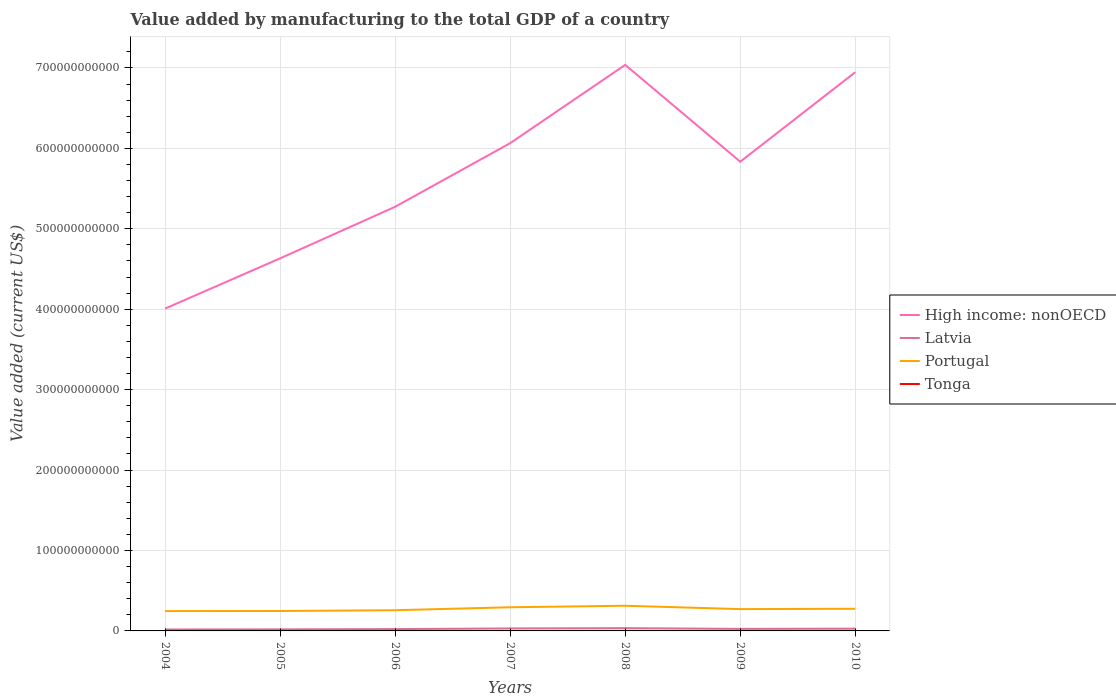Across all years, what is the maximum value added by manufacturing to the total GDP in Tonga?
Offer a terse response. 1.86e+07. In which year was the value added by manufacturing to the total GDP in Latvia maximum?
Your answer should be very brief. 2004. What is the total value added by manufacturing to the total GDP in Latvia in the graph?
Give a very brief answer. -7.93e+08. What is the difference between the highest and the second highest value added by manufacturing to the total GDP in Tonga?
Your answer should be very brief. 4.22e+06. How many years are there in the graph?
Provide a short and direct response. 7. What is the difference between two consecutive major ticks on the Y-axis?
Ensure brevity in your answer.  1.00e+11. Are the values on the major ticks of Y-axis written in scientific E-notation?
Your answer should be very brief. No. Does the graph contain grids?
Your response must be concise. Yes. Where does the legend appear in the graph?
Give a very brief answer. Center right. How are the legend labels stacked?
Ensure brevity in your answer.  Vertical. What is the title of the graph?
Ensure brevity in your answer.  Value added by manufacturing to the total GDP of a country. Does "Isle of Man" appear as one of the legend labels in the graph?
Provide a succinct answer. No. What is the label or title of the Y-axis?
Your response must be concise. Value added (current US$). What is the Value added (current US$) of High income: nonOECD in 2004?
Your response must be concise. 4.01e+11. What is the Value added (current US$) in Latvia in 2004?
Your answer should be compact. 1.78e+09. What is the Value added (current US$) of Portugal in 2004?
Your answer should be very brief. 2.47e+1. What is the Value added (current US$) in Tonga in 2004?
Your answer should be compact. 1.86e+07. What is the Value added (current US$) in High income: nonOECD in 2005?
Offer a very short reply. 4.63e+11. What is the Value added (current US$) in Latvia in 2005?
Provide a short and direct response. 1.95e+09. What is the Value added (current US$) of Portugal in 2005?
Your answer should be compact. 2.48e+1. What is the Value added (current US$) of Tonga in 2005?
Offer a very short reply. 1.94e+07. What is the Value added (current US$) in High income: nonOECD in 2006?
Your answer should be compact. 5.27e+11. What is the Value added (current US$) of Latvia in 2006?
Make the answer very short. 2.29e+09. What is the Value added (current US$) of Portugal in 2006?
Provide a short and direct response. 2.57e+1. What is the Value added (current US$) in Tonga in 2006?
Provide a short and direct response. 2.05e+07. What is the Value added (current US$) of High income: nonOECD in 2007?
Provide a short and direct response. 6.07e+11. What is the Value added (current US$) in Latvia in 2007?
Your answer should be very brief. 3.13e+09. What is the Value added (current US$) of Portugal in 2007?
Your answer should be compact. 2.94e+1. What is the Value added (current US$) in Tonga in 2007?
Provide a succinct answer. 2.17e+07. What is the Value added (current US$) of High income: nonOECD in 2008?
Give a very brief answer. 7.04e+11. What is the Value added (current US$) of Latvia in 2008?
Provide a short and direct response. 3.46e+09. What is the Value added (current US$) in Portugal in 2008?
Keep it short and to the point. 3.13e+1. What is the Value added (current US$) of Tonga in 2008?
Offer a very short reply. 2.29e+07. What is the Value added (current US$) in High income: nonOECD in 2009?
Ensure brevity in your answer.  5.83e+11. What is the Value added (current US$) in Latvia in 2009?
Your response must be concise. 2.57e+09. What is the Value added (current US$) of Portugal in 2009?
Offer a terse response. 2.71e+1. What is the Value added (current US$) in Tonga in 2009?
Offer a terse response. 2.13e+07. What is the Value added (current US$) in High income: nonOECD in 2010?
Your answer should be very brief. 6.95e+11. What is the Value added (current US$) in Latvia in 2010?
Offer a terse response. 2.86e+09. What is the Value added (current US$) of Portugal in 2010?
Your answer should be very brief. 2.76e+1. What is the Value added (current US$) of Tonga in 2010?
Your answer should be compact. 2.27e+07. Across all years, what is the maximum Value added (current US$) of High income: nonOECD?
Give a very brief answer. 7.04e+11. Across all years, what is the maximum Value added (current US$) of Latvia?
Your answer should be very brief. 3.46e+09. Across all years, what is the maximum Value added (current US$) of Portugal?
Your answer should be very brief. 3.13e+1. Across all years, what is the maximum Value added (current US$) in Tonga?
Provide a short and direct response. 2.29e+07. Across all years, what is the minimum Value added (current US$) of High income: nonOECD?
Offer a very short reply. 4.01e+11. Across all years, what is the minimum Value added (current US$) of Latvia?
Give a very brief answer. 1.78e+09. Across all years, what is the minimum Value added (current US$) in Portugal?
Offer a terse response. 2.47e+1. Across all years, what is the minimum Value added (current US$) in Tonga?
Ensure brevity in your answer.  1.86e+07. What is the total Value added (current US$) in High income: nonOECD in the graph?
Your response must be concise. 3.98e+12. What is the total Value added (current US$) in Latvia in the graph?
Keep it short and to the point. 1.80e+1. What is the total Value added (current US$) of Portugal in the graph?
Your answer should be very brief. 1.91e+11. What is the total Value added (current US$) of Tonga in the graph?
Make the answer very short. 1.47e+08. What is the difference between the Value added (current US$) of High income: nonOECD in 2004 and that in 2005?
Your response must be concise. -6.25e+1. What is the difference between the Value added (current US$) in Latvia in 2004 and that in 2005?
Make the answer very short. -1.70e+08. What is the difference between the Value added (current US$) in Portugal in 2004 and that in 2005?
Your answer should be very brief. -1.05e+08. What is the difference between the Value added (current US$) of Tonga in 2004 and that in 2005?
Provide a short and direct response. -7.68e+05. What is the difference between the Value added (current US$) in High income: nonOECD in 2004 and that in 2006?
Offer a very short reply. -1.27e+11. What is the difference between the Value added (current US$) in Latvia in 2004 and that in 2006?
Ensure brevity in your answer.  -5.09e+08. What is the difference between the Value added (current US$) of Portugal in 2004 and that in 2006?
Keep it short and to the point. -1.07e+09. What is the difference between the Value added (current US$) of Tonga in 2004 and that in 2006?
Your answer should be compact. -1.81e+06. What is the difference between the Value added (current US$) in High income: nonOECD in 2004 and that in 2007?
Offer a terse response. -2.06e+11. What is the difference between the Value added (current US$) in Latvia in 2004 and that in 2007?
Ensure brevity in your answer.  -1.35e+09. What is the difference between the Value added (current US$) in Portugal in 2004 and that in 2007?
Provide a succinct answer. -4.73e+09. What is the difference between the Value added (current US$) in Tonga in 2004 and that in 2007?
Provide a short and direct response. -3.09e+06. What is the difference between the Value added (current US$) in High income: nonOECD in 2004 and that in 2008?
Your answer should be very brief. -3.03e+11. What is the difference between the Value added (current US$) of Latvia in 2004 and that in 2008?
Offer a very short reply. -1.68e+09. What is the difference between the Value added (current US$) of Portugal in 2004 and that in 2008?
Your answer should be very brief. -6.62e+09. What is the difference between the Value added (current US$) in Tonga in 2004 and that in 2008?
Your answer should be very brief. -4.22e+06. What is the difference between the Value added (current US$) in High income: nonOECD in 2004 and that in 2009?
Provide a short and direct response. -1.83e+11. What is the difference between the Value added (current US$) of Latvia in 2004 and that in 2009?
Keep it short and to the point. -7.93e+08. What is the difference between the Value added (current US$) of Portugal in 2004 and that in 2009?
Make the answer very short. -2.46e+09. What is the difference between the Value added (current US$) in Tonga in 2004 and that in 2009?
Your answer should be compact. -2.63e+06. What is the difference between the Value added (current US$) of High income: nonOECD in 2004 and that in 2010?
Make the answer very short. -2.94e+11. What is the difference between the Value added (current US$) of Latvia in 2004 and that in 2010?
Keep it short and to the point. -1.08e+09. What is the difference between the Value added (current US$) of Portugal in 2004 and that in 2010?
Give a very brief answer. -2.90e+09. What is the difference between the Value added (current US$) of Tonga in 2004 and that in 2010?
Your answer should be compact. -4.01e+06. What is the difference between the Value added (current US$) in High income: nonOECD in 2005 and that in 2006?
Your answer should be very brief. -6.42e+1. What is the difference between the Value added (current US$) in Latvia in 2005 and that in 2006?
Provide a succinct answer. -3.40e+08. What is the difference between the Value added (current US$) of Portugal in 2005 and that in 2006?
Keep it short and to the point. -9.66e+08. What is the difference between the Value added (current US$) of Tonga in 2005 and that in 2006?
Keep it short and to the point. -1.04e+06. What is the difference between the Value added (current US$) in High income: nonOECD in 2005 and that in 2007?
Provide a short and direct response. -1.43e+11. What is the difference between the Value added (current US$) of Latvia in 2005 and that in 2007?
Keep it short and to the point. -1.18e+09. What is the difference between the Value added (current US$) of Portugal in 2005 and that in 2007?
Keep it short and to the point. -4.63e+09. What is the difference between the Value added (current US$) in Tonga in 2005 and that in 2007?
Ensure brevity in your answer.  -2.32e+06. What is the difference between the Value added (current US$) of High income: nonOECD in 2005 and that in 2008?
Give a very brief answer. -2.41e+11. What is the difference between the Value added (current US$) in Latvia in 2005 and that in 2008?
Make the answer very short. -1.51e+09. What is the difference between the Value added (current US$) in Portugal in 2005 and that in 2008?
Give a very brief answer. -6.52e+09. What is the difference between the Value added (current US$) of Tonga in 2005 and that in 2008?
Your answer should be very brief. -3.46e+06. What is the difference between the Value added (current US$) of High income: nonOECD in 2005 and that in 2009?
Provide a short and direct response. -1.20e+11. What is the difference between the Value added (current US$) in Latvia in 2005 and that in 2009?
Your response must be concise. -6.23e+08. What is the difference between the Value added (current US$) of Portugal in 2005 and that in 2009?
Your answer should be very brief. -2.35e+09. What is the difference between the Value added (current US$) of Tonga in 2005 and that in 2009?
Offer a terse response. -1.87e+06. What is the difference between the Value added (current US$) of High income: nonOECD in 2005 and that in 2010?
Ensure brevity in your answer.  -2.32e+11. What is the difference between the Value added (current US$) in Latvia in 2005 and that in 2010?
Ensure brevity in your answer.  -9.06e+08. What is the difference between the Value added (current US$) of Portugal in 2005 and that in 2010?
Offer a very short reply. -2.80e+09. What is the difference between the Value added (current US$) of Tonga in 2005 and that in 2010?
Provide a short and direct response. -3.24e+06. What is the difference between the Value added (current US$) of High income: nonOECD in 2006 and that in 2007?
Provide a succinct answer. -7.91e+1. What is the difference between the Value added (current US$) in Latvia in 2006 and that in 2007?
Your answer should be very brief. -8.42e+08. What is the difference between the Value added (current US$) of Portugal in 2006 and that in 2007?
Ensure brevity in your answer.  -3.66e+09. What is the difference between the Value added (current US$) of Tonga in 2006 and that in 2007?
Give a very brief answer. -1.28e+06. What is the difference between the Value added (current US$) in High income: nonOECD in 2006 and that in 2008?
Offer a terse response. -1.76e+11. What is the difference between the Value added (current US$) of Latvia in 2006 and that in 2008?
Ensure brevity in your answer.  -1.17e+09. What is the difference between the Value added (current US$) in Portugal in 2006 and that in 2008?
Your response must be concise. -5.55e+09. What is the difference between the Value added (current US$) of Tonga in 2006 and that in 2008?
Your answer should be compact. -2.42e+06. What is the difference between the Value added (current US$) of High income: nonOECD in 2006 and that in 2009?
Keep it short and to the point. -5.60e+1. What is the difference between the Value added (current US$) in Latvia in 2006 and that in 2009?
Keep it short and to the point. -2.83e+08. What is the difference between the Value added (current US$) of Portugal in 2006 and that in 2009?
Offer a very short reply. -1.39e+09. What is the difference between the Value added (current US$) in Tonga in 2006 and that in 2009?
Ensure brevity in your answer.  -8.28e+05. What is the difference between the Value added (current US$) of High income: nonOECD in 2006 and that in 2010?
Make the answer very short. -1.67e+11. What is the difference between the Value added (current US$) in Latvia in 2006 and that in 2010?
Ensure brevity in your answer.  -5.66e+08. What is the difference between the Value added (current US$) in Portugal in 2006 and that in 2010?
Provide a short and direct response. -1.83e+09. What is the difference between the Value added (current US$) of Tonga in 2006 and that in 2010?
Your answer should be compact. -2.20e+06. What is the difference between the Value added (current US$) of High income: nonOECD in 2007 and that in 2008?
Offer a terse response. -9.74e+1. What is the difference between the Value added (current US$) in Latvia in 2007 and that in 2008?
Your response must be concise. -3.26e+08. What is the difference between the Value added (current US$) in Portugal in 2007 and that in 2008?
Offer a very short reply. -1.89e+09. What is the difference between the Value added (current US$) of Tonga in 2007 and that in 2008?
Keep it short and to the point. -1.13e+06. What is the difference between the Value added (current US$) of High income: nonOECD in 2007 and that in 2009?
Keep it short and to the point. 2.30e+1. What is the difference between the Value added (current US$) in Latvia in 2007 and that in 2009?
Keep it short and to the point. 5.58e+08. What is the difference between the Value added (current US$) in Portugal in 2007 and that in 2009?
Your answer should be compact. 2.28e+09. What is the difference between the Value added (current US$) in Tonga in 2007 and that in 2009?
Offer a very short reply. 4.56e+05. What is the difference between the Value added (current US$) of High income: nonOECD in 2007 and that in 2010?
Offer a very short reply. -8.83e+1. What is the difference between the Value added (current US$) in Latvia in 2007 and that in 2010?
Your answer should be very brief. 2.75e+08. What is the difference between the Value added (current US$) in Portugal in 2007 and that in 2010?
Your response must be concise. 1.83e+09. What is the difference between the Value added (current US$) of Tonga in 2007 and that in 2010?
Offer a terse response. -9.18e+05. What is the difference between the Value added (current US$) of High income: nonOECD in 2008 and that in 2009?
Provide a succinct answer. 1.20e+11. What is the difference between the Value added (current US$) in Latvia in 2008 and that in 2009?
Make the answer very short. 8.85e+08. What is the difference between the Value added (current US$) of Portugal in 2008 and that in 2009?
Keep it short and to the point. 4.16e+09. What is the difference between the Value added (current US$) in Tonga in 2008 and that in 2009?
Provide a succinct answer. 1.59e+06. What is the difference between the Value added (current US$) of High income: nonOECD in 2008 and that in 2010?
Provide a succinct answer. 9.09e+09. What is the difference between the Value added (current US$) in Latvia in 2008 and that in 2010?
Your answer should be compact. 6.01e+08. What is the difference between the Value added (current US$) in Portugal in 2008 and that in 2010?
Provide a succinct answer. 3.72e+09. What is the difference between the Value added (current US$) in Tonga in 2008 and that in 2010?
Your answer should be very brief. 2.15e+05. What is the difference between the Value added (current US$) in High income: nonOECD in 2009 and that in 2010?
Offer a very short reply. -1.11e+11. What is the difference between the Value added (current US$) of Latvia in 2009 and that in 2010?
Your answer should be very brief. -2.83e+08. What is the difference between the Value added (current US$) of Portugal in 2009 and that in 2010?
Offer a very short reply. -4.47e+08. What is the difference between the Value added (current US$) in Tonga in 2009 and that in 2010?
Your response must be concise. -1.37e+06. What is the difference between the Value added (current US$) of High income: nonOECD in 2004 and the Value added (current US$) of Latvia in 2005?
Offer a very short reply. 3.99e+11. What is the difference between the Value added (current US$) in High income: nonOECD in 2004 and the Value added (current US$) in Portugal in 2005?
Offer a terse response. 3.76e+11. What is the difference between the Value added (current US$) of High income: nonOECD in 2004 and the Value added (current US$) of Tonga in 2005?
Your response must be concise. 4.01e+11. What is the difference between the Value added (current US$) of Latvia in 2004 and the Value added (current US$) of Portugal in 2005?
Your answer should be compact. -2.30e+1. What is the difference between the Value added (current US$) of Latvia in 2004 and the Value added (current US$) of Tonga in 2005?
Give a very brief answer. 1.76e+09. What is the difference between the Value added (current US$) in Portugal in 2004 and the Value added (current US$) in Tonga in 2005?
Make the answer very short. 2.47e+1. What is the difference between the Value added (current US$) of High income: nonOECD in 2004 and the Value added (current US$) of Latvia in 2006?
Provide a succinct answer. 3.98e+11. What is the difference between the Value added (current US$) in High income: nonOECD in 2004 and the Value added (current US$) in Portugal in 2006?
Give a very brief answer. 3.75e+11. What is the difference between the Value added (current US$) in High income: nonOECD in 2004 and the Value added (current US$) in Tonga in 2006?
Give a very brief answer. 4.01e+11. What is the difference between the Value added (current US$) of Latvia in 2004 and the Value added (current US$) of Portugal in 2006?
Offer a very short reply. -2.40e+1. What is the difference between the Value added (current US$) in Latvia in 2004 and the Value added (current US$) in Tonga in 2006?
Give a very brief answer. 1.76e+09. What is the difference between the Value added (current US$) in Portugal in 2004 and the Value added (current US$) in Tonga in 2006?
Provide a succinct answer. 2.47e+1. What is the difference between the Value added (current US$) in High income: nonOECD in 2004 and the Value added (current US$) in Latvia in 2007?
Your answer should be very brief. 3.98e+11. What is the difference between the Value added (current US$) of High income: nonOECD in 2004 and the Value added (current US$) of Portugal in 2007?
Offer a terse response. 3.71e+11. What is the difference between the Value added (current US$) of High income: nonOECD in 2004 and the Value added (current US$) of Tonga in 2007?
Your answer should be compact. 4.01e+11. What is the difference between the Value added (current US$) in Latvia in 2004 and the Value added (current US$) in Portugal in 2007?
Give a very brief answer. -2.76e+1. What is the difference between the Value added (current US$) of Latvia in 2004 and the Value added (current US$) of Tonga in 2007?
Your response must be concise. 1.76e+09. What is the difference between the Value added (current US$) in Portugal in 2004 and the Value added (current US$) in Tonga in 2007?
Your answer should be compact. 2.47e+1. What is the difference between the Value added (current US$) of High income: nonOECD in 2004 and the Value added (current US$) of Latvia in 2008?
Provide a succinct answer. 3.97e+11. What is the difference between the Value added (current US$) in High income: nonOECD in 2004 and the Value added (current US$) in Portugal in 2008?
Make the answer very short. 3.69e+11. What is the difference between the Value added (current US$) of High income: nonOECD in 2004 and the Value added (current US$) of Tonga in 2008?
Your answer should be compact. 4.01e+11. What is the difference between the Value added (current US$) of Latvia in 2004 and the Value added (current US$) of Portugal in 2008?
Provide a succinct answer. -2.95e+1. What is the difference between the Value added (current US$) in Latvia in 2004 and the Value added (current US$) in Tonga in 2008?
Your answer should be very brief. 1.76e+09. What is the difference between the Value added (current US$) of Portugal in 2004 and the Value added (current US$) of Tonga in 2008?
Ensure brevity in your answer.  2.47e+1. What is the difference between the Value added (current US$) of High income: nonOECD in 2004 and the Value added (current US$) of Latvia in 2009?
Your response must be concise. 3.98e+11. What is the difference between the Value added (current US$) of High income: nonOECD in 2004 and the Value added (current US$) of Portugal in 2009?
Keep it short and to the point. 3.74e+11. What is the difference between the Value added (current US$) of High income: nonOECD in 2004 and the Value added (current US$) of Tonga in 2009?
Ensure brevity in your answer.  4.01e+11. What is the difference between the Value added (current US$) in Latvia in 2004 and the Value added (current US$) in Portugal in 2009?
Make the answer very short. -2.54e+1. What is the difference between the Value added (current US$) of Latvia in 2004 and the Value added (current US$) of Tonga in 2009?
Provide a short and direct response. 1.76e+09. What is the difference between the Value added (current US$) of Portugal in 2004 and the Value added (current US$) of Tonga in 2009?
Your response must be concise. 2.47e+1. What is the difference between the Value added (current US$) of High income: nonOECD in 2004 and the Value added (current US$) of Latvia in 2010?
Keep it short and to the point. 3.98e+11. What is the difference between the Value added (current US$) of High income: nonOECD in 2004 and the Value added (current US$) of Portugal in 2010?
Provide a succinct answer. 3.73e+11. What is the difference between the Value added (current US$) of High income: nonOECD in 2004 and the Value added (current US$) of Tonga in 2010?
Your answer should be very brief. 4.01e+11. What is the difference between the Value added (current US$) in Latvia in 2004 and the Value added (current US$) in Portugal in 2010?
Provide a short and direct response. -2.58e+1. What is the difference between the Value added (current US$) in Latvia in 2004 and the Value added (current US$) in Tonga in 2010?
Offer a very short reply. 1.76e+09. What is the difference between the Value added (current US$) of Portugal in 2004 and the Value added (current US$) of Tonga in 2010?
Offer a terse response. 2.47e+1. What is the difference between the Value added (current US$) of High income: nonOECD in 2005 and the Value added (current US$) of Latvia in 2006?
Your answer should be compact. 4.61e+11. What is the difference between the Value added (current US$) in High income: nonOECD in 2005 and the Value added (current US$) in Portugal in 2006?
Offer a terse response. 4.38e+11. What is the difference between the Value added (current US$) of High income: nonOECD in 2005 and the Value added (current US$) of Tonga in 2006?
Provide a short and direct response. 4.63e+11. What is the difference between the Value added (current US$) of Latvia in 2005 and the Value added (current US$) of Portugal in 2006?
Offer a very short reply. -2.38e+1. What is the difference between the Value added (current US$) in Latvia in 2005 and the Value added (current US$) in Tonga in 2006?
Keep it short and to the point. 1.93e+09. What is the difference between the Value added (current US$) of Portugal in 2005 and the Value added (current US$) of Tonga in 2006?
Make the answer very short. 2.48e+1. What is the difference between the Value added (current US$) of High income: nonOECD in 2005 and the Value added (current US$) of Latvia in 2007?
Offer a very short reply. 4.60e+11. What is the difference between the Value added (current US$) of High income: nonOECD in 2005 and the Value added (current US$) of Portugal in 2007?
Your response must be concise. 4.34e+11. What is the difference between the Value added (current US$) in High income: nonOECD in 2005 and the Value added (current US$) in Tonga in 2007?
Your answer should be compact. 4.63e+11. What is the difference between the Value added (current US$) in Latvia in 2005 and the Value added (current US$) in Portugal in 2007?
Provide a short and direct response. -2.75e+1. What is the difference between the Value added (current US$) of Latvia in 2005 and the Value added (current US$) of Tonga in 2007?
Keep it short and to the point. 1.93e+09. What is the difference between the Value added (current US$) of Portugal in 2005 and the Value added (current US$) of Tonga in 2007?
Offer a terse response. 2.48e+1. What is the difference between the Value added (current US$) in High income: nonOECD in 2005 and the Value added (current US$) in Latvia in 2008?
Ensure brevity in your answer.  4.60e+11. What is the difference between the Value added (current US$) of High income: nonOECD in 2005 and the Value added (current US$) of Portugal in 2008?
Give a very brief answer. 4.32e+11. What is the difference between the Value added (current US$) of High income: nonOECD in 2005 and the Value added (current US$) of Tonga in 2008?
Ensure brevity in your answer.  4.63e+11. What is the difference between the Value added (current US$) in Latvia in 2005 and the Value added (current US$) in Portugal in 2008?
Give a very brief answer. -2.93e+1. What is the difference between the Value added (current US$) of Latvia in 2005 and the Value added (current US$) of Tonga in 2008?
Make the answer very short. 1.93e+09. What is the difference between the Value added (current US$) in Portugal in 2005 and the Value added (current US$) in Tonga in 2008?
Keep it short and to the point. 2.48e+1. What is the difference between the Value added (current US$) in High income: nonOECD in 2005 and the Value added (current US$) in Latvia in 2009?
Your answer should be very brief. 4.61e+11. What is the difference between the Value added (current US$) in High income: nonOECD in 2005 and the Value added (current US$) in Portugal in 2009?
Keep it short and to the point. 4.36e+11. What is the difference between the Value added (current US$) in High income: nonOECD in 2005 and the Value added (current US$) in Tonga in 2009?
Give a very brief answer. 4.63e+11. What is the difference between the Value added (current US$) of Latvia in 2005 and the Value added (current US$) of Portugal in 2009?
Provide a succinct answer. -2.52e+1. What is the difference between the Value added (current US$) of Latvia in 2005 and the Value added (current US$) of Tonga in 2009?
Your response must be concise. 1.93e+09. What is the difference between the Value added (current US$) in Portugal in 2005 and the Value added (current US$) in Tonga in 2009?
Make the answer very short. 2.48e+1. What is the difference between the Value added (current US$) in High income: nonOECD in 2005 and the Value added (current US$) in Latvia in 2010?
Your answer should be compact. 4.60e+11. What is the difference between the Value added (current US$) of High income: nonOECD in 2005 and the Value added (current US$) of Portugal in 2010?
Offer a very short reply. 4.36e+11. What is the difference between the Value added (current US$) of High income: nonOECD in 2005 and the Value added (current US$) of Tonga in 2010?
Ensure brevity in your answer.  4.63e+11. What is the difference between the Value added (current US$) in Latvia in 2005 and the Value added (current US$) in Portugal in 2010?
Offer a very short reply. -2.56e+1. What is the difference between the Value added (current US$) of Latvia in 2005 and the Value added (current US$) of Tonga in 2010?
Keep it short and to the point. 1.93e+09. What is the difference between the Value added (current US$) in Portugal in 2005 and the Value added (current US$) in Tonga in 2010?
Ensure brevity in your answer.  2.48e+1. What is the difference between the Value added (current US$) of High income: nonOECD in 2006 and the Value added (current US$) of Latvia in 2007?
Offer a very short reply. 5.24e+11. What is the difference between the Value added (current US$) of High income: nonOECD in 2006 and the Value added (current US$) of Portugal in 2007?
Give a very brief answer. 4.98e+11. What is the difference between the Value added (current US$) in High income: nonOECD in 2006 and the Value added (current US$) in Tonga in 2007?
Your answer should be compact. 5.27e+11. What is the difference between the Value added (current US$) in Latvia in 2006 and the Value added (current US$) in Portugal in 2007?
Make the answer very short. -2.71e+1. What is the difference between the Value added (current US$) of Latvia in 2006 and the Value added (current US$) of Tonga in 2007?
Your answer should be very brief. 2.27e+09. What is the difference between the Value added (current US$) in Portugal in 2006 and the Value added (current US$) in Tonga in 2007?
Provide a succinct answer. 2.57e+1. What is the difference between the Value added (current US$) in High income: nonOECD in 2006 and the Value added (current US$) in Latvia in 2008?
Your answer should be very brief. 5.24e+11. What is the difference between the Value added (current US$) in High income: nonOECD in 2006 and the Value added (current US$) in Portugal in 2008?
Make the answer very short. 4.96e+11. What is the difference between the Value added (current US$) of High income: nonOECD in 2006 and the Value added (current US$) of Tonga in 2008?
Make the answer very short. 5.27e+11. What is the difference between the Value added (current US$) of Latvia in 2006 and the Value added (current US$) of Portugal in 2008?
Offer a very short reply. -2.90e+1. What is the difference between the Value added (current US$) in Latvia in 2006 and the Value added (current US$) in Tonga in 2008?
Provide a succinct answer. 2.27e+09. What is the difference between the Value added (current US$) in Portugal in 2006 and the Value added (current US$) in Tonga in 2008?
Offer a very short reply. 2.57e+1. What is the difference between the Value added (current US$) of High income: nonOECD in 2006 and the Value added (current US$) of Latvia in 2009?
Your response must be concise. 5.25e+11. What is the difference between the Value added (current US$) of High income: nonOECD in 2006 and the Value added (current US$) of Portugal in 2009?
Make the answer very short. 5.00e+11. What is the difference between the Value added (current US$) of High income: nonOECD in 2006 and the Value added (current US$) of Tonga in 2009?
Keep it short and to the point. 5.27e+11. What is the difference between the Value added (current US$) in Latvia in 2006 and the Value added (current US$) in Portugal in 2009?
Keep it short and to the point. -2.48e+1. What is the difference between the Value added (current US$) in Latvia in 2006 and the Value added (current US$) in Tonga in 2009?
Make the answer very short. 2.27e+09. What is the difference between the Value added (current US$) of Portugal in 2006 and the Value added (current US$) of Tonga in 2009?
Your answer should be compact. 2.57e+1. What is the difference between the Value added (current US$) in High income: nonOECD in 2006 and the Value added (current US$) in Latvia in 2010?
Your answer should be very brief. 5.25e+11. What is the difference between the Value added (current US$) in High income: nonOECD in 2006 and the Value added (current US$) in Portugal in 2010?
Your answer should be very brief. 5.00e+11. What is the difference between the Value added (current US$) of High income: nonOECD in 2006 and the Value added (current US$) of Tonga in 2010?
Ensure brevity in your answer.  5.27e+11. What is the difference between the Value added (current US$) in Latvia in 2006 and the Value added (current US$) in Portugal in 2010?
Keep it short and to the point. -2.53e+1. What is the difference between the Value added (current US$) in Latvia in 2006 and the Value added (current US$) in Tonga in 2010?
Ensure brevity in your answer.  2.27e+09. What is the difference between the Value added (current US$) of Portugal in 2006 and the Value added (current US$) of Tonga in 2010?
Make the answer very short. 2.57e+1. What is the difference between the Value added (current US$) of High income: nonOECD in 2007 and the Value added (current US$) of Latvia in 2008?
Make the answer very short. 6.03e+11. What is the difference between the Value added (current US$) in High income: nonOECD in 2007 and the Value added (current US$) in Portugal in 2008?
Your response must be concise. 5.75e+11. What is the difference between the Value added (current US$) in High income: nonOECD in 2007 and the Value added (current US$) in Tonga in 2008?
Provide a short and direct response. 6.06e+11. What is the difference between the Value added (current US$) of Latvia in 2007 and the Value added (current US$) of Portugal in 2008?
Your answer should be compact. -2.82e+1. What is the difference between the Value added (current US$) in Latvia in 2007 and the Value added (current US$) in Tonga in 2008?
Give a very brief answer. 3.11e+09. What is the difference between the Value added (current US$) of Portugal in 2007 and the Value added (current US$) of Tonga in 2008?
Give a very brief answer. 2.94e+1. What is the difference between the Value added (current US$) of High income: nonOECD in 2007 and the Value added (current US$) of Latvia in 2009?
Give a very brief answer. 6.04e+11. What is the difference between the Value added (current US$) in High income: nonOECD in 2007 and the Value added (current US$) in Portugal in 2009?
Your answer should be compact. 5.79e+11. What is the difference between the Value added (current US$) of High income: nonOECD in 2007 and the Value added (current US$) of Tonga in 2009?
Provide a succinct answer. 6.06e+11. What is the difference between the Value added (current US$) of Latvia in 2007 and the Value added (current US$) of Portugal in 2009?
Offer a very short reply. -2.40e+1. What is the difference between the Value added (current US$) of Latvia in 2007 and the Value added (current US$) of Tonga in 2009?
Provide a succinct answer. 3.11e+09. What is the difference between the Value added (current US$) of Portugal in 2007 and the Value added (current US$) of Tonga in 2009?
Your response must be concise. 2.94e+1. What is the difference between the Value added (current US$) of High income: nonOECD in 2007 and the Value added (current US$) of Latvia in 2010?
Keep it short and to the point. 6.04e+11. What is the difference between the Value added (current US$) of High income: nonOECD in 2007 and the Value added (current US$) of Portugal in 2010?
Ensure brevity in your answer.  5.79e+11. What is the difference between the Value added (current US$) in High income: nonOECD in 2007 and the Value added (current US$) in Tonga in 2010?
Make the answer very short. 6.06e+11. What is the difference between the Value added (current US$) in Latvia in 2007 and the Value added (current US$) in Portugal in 2010?
Ensure brevity in your answer.  -2.44e+1. What is the difference between the Value added (current US$) in Latvia in 2007 and the Value added (current US$) in Tonga in 2010?
Ensure brevity in your answer.  3.11e+09. What is the difference between the Value added (current US$) of Portugal in 2007 and the Value added (current US$) of Tonga in 2010?
Ensure brevity in your answer.  2.94e+1. What is the difference between the Value added (current US$) in High income: nonOECD in 2008 and the Value added (current US$) in Latvia in 2009?
Give a very brief answer. 7.01e+11. What is the difference between the Value added (current US$) in High income: nonOECD in 2008 and the Value added (current US$) in Portugal in 2009?
Your answer should be very brief. 6.77e+11. What is the difference between the Value added (current US$) of High income: nonOECD in 2008 and the Value added (current US$) of Tonga in 2009?
Offer a terse response. 7.04e+11. What is the difference between the Value added (current US$) of Latvia in 2008 and the Value added (current US$) of Portugal in 2009?
Make the answer very short. -2.37e+1. What is the difference between the Value added (current US$) in Latvia in 2008 and the Value added (current US$) in Tonga in 2009?
Offer a terse response. 3.44e+09. What is the difference between the Value added (current US$) of Portugal in 2008 and the Value added (current US$) of Tonga in 2009?
Your response must be concise. 3.13e+1. What is the difference between the Value added (current US$) in High income: nonOECD in 2008 and the Value added (current US$) in Latvia in 2010?
Give a very brief answer. 7.01e+11. What is the difference between the Value added (current US$) of High income: nonOECD in 2008 and the Value added (current US$) of Portugal in 2010?
Provide a short and direct response. 6.76e+11. What is the difference between the Value added (current US$) of High income: nonOECD in 2008 and the Value added (current US$) of Tonga in 2010?
Your answer should be compact. 7.04e+11. What is the difference between the Value added (current US$) in Latvia in 2008 and the Value added (current US$) in Portugal in 2010?
Your response must be concise. -2.41e+1. What is the difference between the Value added (current US$) of Latvia in 2008 and the Value added (current US$) of Tonga in 2010?
Ensure brevity in your answer.  3.43e+09. What is the difference between the Value added (current US$) of Portugal in 2008 and the Value added (current US$) of Tonga in 2010?
Give a very brief answer. 3.13e+1. What is the difference between the Value added (current US$) of High income: nonOECD in 2009 and the Value added (current US$) of Latvia in 2010?
Ensure brevity in your answer.  5.81e+11. What is the difference between the Value added (current US$) in High income: nonOECD in 2009 and the Value added (current US$) in Portugal in 2010?
Provide a short and direct response. 5.56e+11. What is the difference between the Value added (current US$) of High income: nonOECD in 2009 and the Value added (current US$) of Tonga in 2010?
Your answer should be compact. 5.83e+11. What is the difference between the Value added (current US$) in Latvia in 2009 and the Value added (current US$) in Portugal in 2010?
Provide a succinct answer. -2.50e+1. What is the difference between the Value added (current US$) of Latvia in 2009 and the Value added (current US$) of Tonga in 2010?
Offer a very short reply. 2.55e+09. What is the difference between the Value added (current US$) in Portugal in 2009 and the Value added (current US$) in Tonga in 2010?
Make the answer very short. 2.71e+1. What is the average Value added (current US$) of High income: nonOECD per year?
Offer a very short reply. 5.69e+11. What is the average Value added (current US$) in Latvia per year?
Make the answer very short. 2.58e+09. What is the average Value added (current US$) in Portugal per year?
Ensure brevity in your answer.  2.72e+1. What is the average Value added (current US$) of Tonga per year?
Offer a very short reply. 2.10e+07. In the year 2004, what is the difference between the Value added (current US$) in High income: nonOECD and Value added (current US$) in Latvia?
Your answer should be very brief. 3.99e+11. In the year 2004, what is the difference between the Value added (current US$) of High income: nonOECD and Value added (current US$) of Portugal?
Keep it short and to the point. 3.76e+11. In the year 2004, what is the difference between the Value added (current US$) in High income: nonOECD and Value added (current US$) in Tonga?
Your answer should be very brief. 4.01e+11. In the year 2004, what is the difference between the Value added (current US$) in Latvia and Value added (current US$) in Portugal?
Make the answer very short. -2.29e+1. In the year 2004, what is the difference between the Value added (current US$) in Latvia and Value added (current US$) in Tonga?
Your answer should be very brief. 1.76e+09. In the year 2004, what is the difference between the Value added (current US$) of Portugal and Value added (current US$) of Tonga?
Your answer should be very brief. 2.47e+1. In the year 2005, what is the difference between the Value added (current US$) in High income: nonOECD and Value added (current US$) in Latvia?
Give a very brief answer. 4.61e+11. In the year 2005, what is the difference between the Value added (current US$) in High income: nonOECD and Value added (current US$) in Portugal?
Provide a short and direct response. 4.38e+11. In the year 2005, what is the difference between the Value added (current US$) of High income: nonOECD and Value added (current US$) of Tonga?
Offer a terse response. 4.63e+11. In the year 2005, what is the difference between the Value added (current US$) of Latvia and Value added (current US$) of Portugal?
Provide a succinct answer. -2.28e+1. In the year 2005, what is the difference between the Value added (current US$) of Latvia and Value added (current US$) of Tonga?
Your answer should be very brief. 1.93e+09. In the year 2005, what is the difference between the Value added (current US$) of Portugal and Value added (current US$) of Tonga?
Make the answer very short. 2.48e+1. In the year 2006, what is the difference between the Value added (current US$) in High income: nonOECD and Value added (current US$) in Latvia?
Your answer should be very brief. 5.25e+11. In the year 2006, what is the difference between the Value added (current US$) of High income: nonOECD and Value added (current US$) of Portugal?
Your answer should be compact. 5.02e+11. In the year 2006, what is the difference between the Value added (current US$) in High income: nonOECD and Value added (current US$) in Tonga?
Provide a succinct answer. 5.27e+11. In the year 2006, what is the difference between the Value added (current US$) of Latvia and Value added (current US$) of Portugal?
Provide a succinct answer. -2.35e+1. In the year 2006, what is the difference between the Value added (current US$) of Latvia and Value added (current US$) of Tonga?
Your answer should be compact. 2.27e+09. In the year 2006, what is the difference between the Value added (current US$) of Portugal and Value added (current US$) of Tonga?
Offer a terse response. 2.57e+1. In the year 2007, what is the difference between the Value added (current US$) of High income: nonOECD and Value added (current US$) of Latvia?
Keep it short and to the point. 6.03e+11. In the year 2007, what is the difference between the Value added (current US$) of High income: nonOECD and Value added (current US$) of Portugal?
Provide a succinct answer. 5.77e+11. In the year 2007, what is the difference between the Value added (current US$) of High income: nonOECD and Value added (current US$) of Tonga?
Provide a short and direct response. 6.06e+11. In the year 2007, what is the difference between the Value added (current US$) of Latvia and Value added (current US$) of Portugal?
Your answer should be compact. -2.63e+1. In the year 2007, what is the difference between the Value added (current US$) in Latvia and Value added (current US$) in Tonga?
Your answer should be very brief. 3.11e+09. In the year 2007, what is the difference between the Value added (current US$) of Portugal and Value added (current US$) of Tonga?
Offer a very short reply. 2.94e+1. In the year 2008, what is the difference between the Value added (current US$) of High income: nonOECD and Value added (current US$) of Latvia?
Your answer should be compact. 7.00e+11. In the year 2008, what is the difference between the Value added (current US$) of High income: nonOECD and Value added (current US$) of Portugal?
Ensure brevity in your answer.  6.73e+11. In the year 2008, what is the difference between the Value added (current US$) of High income: nonOECD and Value added (current US$) of Tonga?
Keep it short and to the point. 7.04e+11. In the year 2008, what is the difference between the Value added (current US$) in Latvia and Value added (current US$) in Portugal?
Offer a very short reply. -2.78e+1. In the year 2008, what is the difference between the Value added (current US$) of Latvia and Value added (current US$) of Tonga?
Your answer should be very brief. 3.43e+09. In the year 2008, what is the difference between the Value added (current US$) of Portugal and Value added (current US$) of Tonga?
Ensure brevity in your answer.  3.13e+1. In the year 2009, what is the difference between the Value added (current US$) in High income: nonOECD and Value added (current US$) in Latvia?
Offer a terse response. 5.81e+11. In the year 2009, what is the difference between the Value added (current US$) of High income: nonOECD and Value added (current US$) of Portugal?
Give a very brief answer. 5.56e+11. In the year 2009, what is the difference between the Value added (current US$) in High income: nonOECD and Value added (current US$) in Tonga?
Keep it short and to the point. 5.83e+11. In the year 2009, what is the difference between the Value added (current US$) of Latvia and Value added (current US$) of Portugal?
Give a very brief answer. -2.46e+1. In the year 2009, what is the difference between the Value added (current US$) of Latvia and Value added (current US$) of Tonga?
Your response must be concise. 2.55e+09. In the year 2009, what is the difference between the Value added (current US$) in Portugal and Value added (current US$) in Tonga?
Provide a short and direct response. 2.71e+1. In the year 2010, what is the difference between the Value added (current US$) in High income: nonOECD and Value added (current US$) in Latvia?
Your answer should be compact. 6.92e+11. In the year 2010, what is the difference between the Value added (current US$) in High income: nonOECD and Value added (current US$) in Portugal?
Offer a very short reply. 6.67e+11. In the year 2010, what is the difference between the Value added (current US$) in High income: nonOECD and Value added (current US$) in Tonga?
Your answer should be very brief. 6.95e+11. In the year 2010, what is the difference between the Value added (current US$) of Latvia and Value added (current US$) of Portugal?
Your answer should be very brief. -2.47e+1. In the year 2010, what is the difference between the Value added (current US$) in Latvia and Value added (current US$) in Tonga?
Offer a very short reply. 2.83e+09. In the year 2010, what is the difference between the Value added (current US$) in Portugal and Value added (current US$) in Tonga?
Provide a short and direct response. 2.76e+1. What is the ratio of the Value added (current US$) of High income: nonOECD in 2004 to that in 2005?
Provide a succinct answer. 0.87. What is the ratio of the Value added (current US$) in Latvia in 2004 to that in 2005?
Keep it short and to the point. 0.91. What is the ratio of the Value added (current US$) of Portugal in 2004 to that in 2005?
Your response must be concise. 1. What is the ratio of the Value added (current US$) in Tonga in 2004 to that in 2005?
Ensure brevity in your answer.  0.96. What is the ratio of the Value added (current US$) of High income: nonOECD in 2004 to that in 2006?
Offer a terse response. 0.76. What is the ratio of the Value added (current US$) of Latvia in 2004 to that in 2006?
Your answer should be very brief. 0.78. What is the ratio of the Value added (current US$) in Portugal in 2004 to that in 2006?
Your response must be concise. 0.96. What is the ratio of the Value added (current US$) of Tonga in 2004 to that in 2006?
Your answer should be very brief. 0.91. What is the ratio of the Value added (current US$) in High income: nonOECD in 2004 to that in 2007?
Give a very brief answer. 0.66. What is the ratio of the Value added (current US$) of Latvia in 2004 to that in 2007?
Ensure brevity in your answer.  0.57. What is the ratio of the Value added (current US$) of Portugal in 2004 to that in 2007?
Your answer should be very brief. 0.84. What is the ratio of the Value added (current US$) in Tonga in 2004 to that in 2007?
Provide a succinct answer. 0.86. What is the ratio of the Value added (current US$) of High income: nonOECD in 2004 to that in 2008?
Keep it short and to the point. 0.57. What is the ratio of the Value added (current US$) of Latvia in 2004 to that in 2008?
Offer a terse response. 0.51. What is the ratio of the Value added (current US$) in Portugal in 2004 to that in 2008?
Offer a terse response. 0.79. What is the ratio of the Value added (current US$) of Tonga in 2004 to that in 2008?
Provide a short and direct response. 0.82. What is the ratio of the Value added (current US$) of High income: nonOECD in 2004 to that in 2009?
Offer a very short reply. 0.69. What is the ratio of the Value added (current US$) in Latvia in 2004 to that in 2009?
Your answer should be compact. 0.69. What is the ratio of the Value added (current US$) of Portugal in 2004 to that in 2009?
Provide a short and direct response. 0.91. What is the ratio of the Value added (current US$) of Tonga in 2004 to that in 2009?
Offer a very short reply. 0.88. What is the ratio of the Value added (current US$) in High income: nonOECD in 2004 to that in 2010?
Keep it short and to the point. 0.58. What is the ratio of the Value added (current US$) of Latvia in 2004 to that in 2010?
Make the answer very short. 0.62. What is the ratio of the Value added (current US$) of Portugal in 2004 to that in 2010?
Keep it short and to the point. 0.89. What is the ratio of the Value added (current US$) in Tonga in 2004 to that in 2010?
Keep it short and to the point. 0.82. What is the ratio of the Value added (current US$) in High income: nonOECD in 2005 to that in 2006?
Ensure brevity in your answer.  0.88. What is the ratio of the Value added (current US$) in Latvia in 2005 to that in 2006?
Keep it short and to the point. 0.85. What is the ratio of the Value added (current US$) in Portugal in 2005 to that in 2006?
Ensure brevity in your answer.  0.96. What is the ratio of the Value added (current US$) of Tonga in 2005 to that in 2006?
Your answer should be very brief. 0.95. What is the ratio of the Value added (current US$) of High income: nonOECD in 2005 to that in 2007?
Ensure brevity in your answer.  0.76. What is the ratio of the Value added (current US$) of Latvia in 2005 to that in 2007?
Give a very brief answer. 0.62. What is the ratio of the Value added (current US$) in Portugal in 2005 to that in 2007?
Offer a very short reply. 0.84. What is the ratio of the Value added (current US$) of Tonga in 2005 to that in 2007?
Provide a succinct answer. 0.89. What is the ratio of the Value added (current US$) of High income: nonOECD in 2005 to that in 2008?
Give a very brief answer. 0.66. What is the ratio of the Value added (current US$) of Latvia in 2005 to that in 2008?
Provide a succinct answer. 0.56. What is the ratio of the Value added (current US$) of Portugal in 2005 to that in 2008?
Your answer should be compact. 0.79. What is the ratio of the Value added (current US$) in Tonga in 2005 to that in 2008?
Make the answer very short. 0.85. What is the ratio of the Value added (current US$) in High income: nonOECD in 2005 to that in 2009?
Provide a short and direct response. 0.79. What is the ratio of the Value added (current US$) in Latvia in 2005 to that in 2009?
Your answer should be compact. 0.76. What is the ratio of the Value added (current US$) of Portugal in 2005 to that in 2009?
Give a very brief answer. 0.91. What is the ratio of the Value added (current US$) in Tonga in 2005 to that in 2009?
Keep it short and to the point. 0.91. What is the ratio of the Value added (current US$) of High income: nonOECD in 2005 to that in 2010?
Offer a very short reply. 0.67. What is the ratio of the Value added (current US$) in Latvia in 2005 to that in 2010?
Provide a succinct answer. 0.68. What is the ratio of the Value added (current US$) in Portugal in 2005 to that in 2010?
Provide a succinct answer. 0.9. What is the ratio of the Value added (current US$) of Tonga in 2005 to that in 2010?
Provide a succinct answer. 0.86. What is the ratio of the Value added (current US$) of High income: nonOECD in 2006 to that in 2007?
Your answer should be compact. 0.87. What is the ratio of the Value added (current US$) in Latvia in 2006 to that in 2007?
Give a very brief answer. 0.73. What is the ratio of the Value added (current US$) in Portugal in 2006 to that in 2007?
Make the answer very short. 0.88. What is the ratio of the Value added (current US$) of Tonga in 2006 to that in 2007?
Make the answer very short. 0.94. What is the ratio of the Value added (current US$) in High income: nonOECD in 2006 to that in 2008?
Provide a succinct answer. 0.75. What is the ratio of the Value added (current US$) of Latvia in 2006 to that in 2008?
Give a very brief answer. 0.66. What is the ratio of the Value added (current US$) of Portugal in 2006 to that in 2008?
Offer a very short reply. 0.82. What is the ratio of the Value added (current US$) in Tonga in 2006 to that in 2008?
Provide a short and direct response. 0.89. What is the ratio of the Value added (current US$) of High income: nonOECD in 2006 to that in 2009?
Make the answer very short. 0.9. What is the ratio of the Value added (current US$) in Latvia in 2006 to that in 2009?
Make the answer very short. 0.89. What is the ratio of the Value added (current US$) of Portugal in 2006 to that in 2009?
Your answer should be compact. 0.95. What is the ratio of the Value added (current US$) of Tonga in 2006 to that in 2009?
Your answer should be compact. 0.96. What is the ratio of the Value added (current US$) in High income: nonOECD in 2006 to that in 2010?
Your answer should be compact. 0.76. What is the ratio of the Value added (current US$) of Latvia in 2006 to that in 2010?
Ensure brevity in your answer.  0.8. What is the ratio of the Value added (current US$) in Portugal in 2006 to that in 2010?
Offer a very short reply. 0.93. What is the ratio of the Value added (current US$) of Tonga in 2006 to that in 2010?
Provide a succinct answer. 0.9. What is the ratio of the Value added (current US$) of High income: nonOECD in 2007 to that in 2008?
Make the answer very short. 0.86. What is the ratio of the Value added (current US$) in Latvia in 2007 to that in 2008?
Give a very brief answer. 0.91. What is the ratio of the Value added (current US$) of Portugal in 2007 to that in 2008?
Provide a succinct answer. 0.94. What is the ratio of the Value added (current US$) of Tonga in 2007 to that in 2008?
Ensure brevity in your answer.  0.95. What is the ratio of the Value added (current US$) of High income: nonOECD in 2007 to that in 2009?
Your response must be concise. 1.04. What is the ratio of the Value added (current US$) in Latvia in 2007 to that in 2009?
Offer a very short reply. 1.22. What is the ratio of the Value added (current US$) in Portugal in 2007 to that in 2009?
Your answer should be very brief. 1.08. What is the ratio of the Value added (current US$) in Tonga in 2007 to that in 2009?
Provide a short and direct response. 1.02. What is the ratio of the Value added (current US$) in High income: nonOECD in 2007 to that in 2010?
Provide a short and direct response. 0.87. What is the ratio of the Value added (current US$) in Latvia in 2007 to that in 2010?
Offer a terse response. 1.1. What is the ratio of the Value added (current US$) of Portugal in 2007 to that in 2010?
Offer a very short reply. 1.07. What is the ratio of the Value added (current US$) in Tonga in 2007 to that in 2010?
Your answer should be very brief. 0.96. What is the ratio of the Value added (current US$) in High income: nonOECD in 2008 to that in 2009?
Make the answer very short. 1.21. What is the ratio of the Value added (current US$) of Latvia in 2008 to that in 2009?
Ensure brevity in your answer.  1.34. What is the ratio of the Value added (current US$) of Portugal in 2008 to that in 2009?
Make the answer very short. 1.15. What is the ratio of the Value added (current US$) of Tonga in 2008 to that in 2009?
Provide a short and direct response. 1.07. What is the ratio of the Value added (current US$) of High income: nonOECD in 2008 to that in 2010?
Your answer should be very brief. 1.01. What is the ratio of the Value added (current US$) of Latvia in 2008 to that in 2010?
Ensure brevity in your answer.  1.21. What is the ratio of the Value added (current US$) in Portugal in 2008 to that in 2010?
Offer a terse response. 1.13. What is the ratio of the Value added (current US$) of Tonga in 2008 to that in 2010?
Ensure brevity in your answer.  1.01. What is the ratio of the Value added (current US$) of High income: nonOECD in 2009 to that in 2010?
Your answer should be very brief. 0.84. What is the ratio of the Value added (current US$) of Latvia in 2009 to that in 2010?
Your response must be concise. 0.9. What is the ratio of the Value added (current US$) in Portugal in 2009 to that in 2010?
Ensure brevity in your answer.  0.98. What is the ratio of the Value added (current US$) of Tonga in 2009 to that in 2010?
Your answer should be very brief. 0.94. What is the difference between the highest and the second highest Value added (current US$) of High income: nonOECD?
Offer a very short reply. 9.09e+09. What is the difference between the highest and the second highest Value added (current US$) in Latvia?
Offer a very short reply. 3.26e+08. What is the difference between the highest and the second highest Value added (current US$) in Portugal?
Give a very brief answer. 1.89e+09. What is the difference between the highest and the second highest Value added (current US$) of Tonga?
Your answer should be very brief. 2.15e+05. What is the difference between the highest and the lowest Value added (current US$) in High income: nonOECD?
Make the answer very short. 3.03e+11. What is the difference between the highest and the lowest Value added (current US$) of Latvia?
Provide a succinct answer. 1.68e+09. What is the difference between the highest and the lowest Value added (current US$) in Portugal?
Offer a very short reply. 6.62e+09. What is the difference between the highest and the lowest Value added (current US$) of Tonga?
Your answer should be compact. 4.22e+06. 